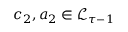<formula> <loc_0><loc_0><loc_500><loc_500>c _ { 2 } , a _ { 2 } \in \mathcal { L } _ { \tau - 1 }</formula> 